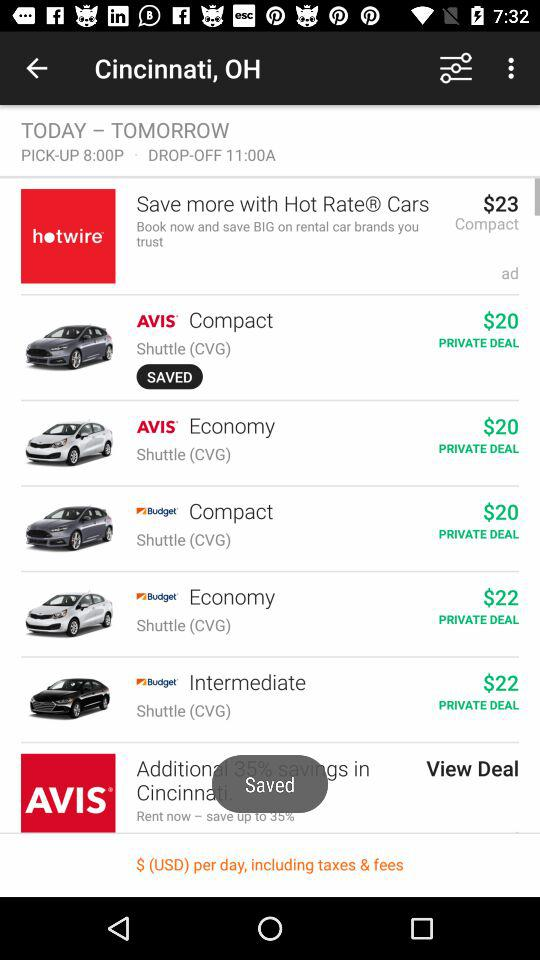How much is the difference in price between the cheapest and most expensive cars?
Answer the question using a single word or phrase. $3 